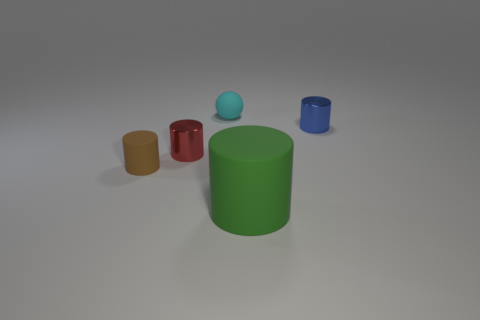How many brown things are either small shiny cylinders or small matte cylinders? In the image, there is only one small shiny cylinder that is brown. No other cylinders, whether shiny or matte, share this color in the photo. 